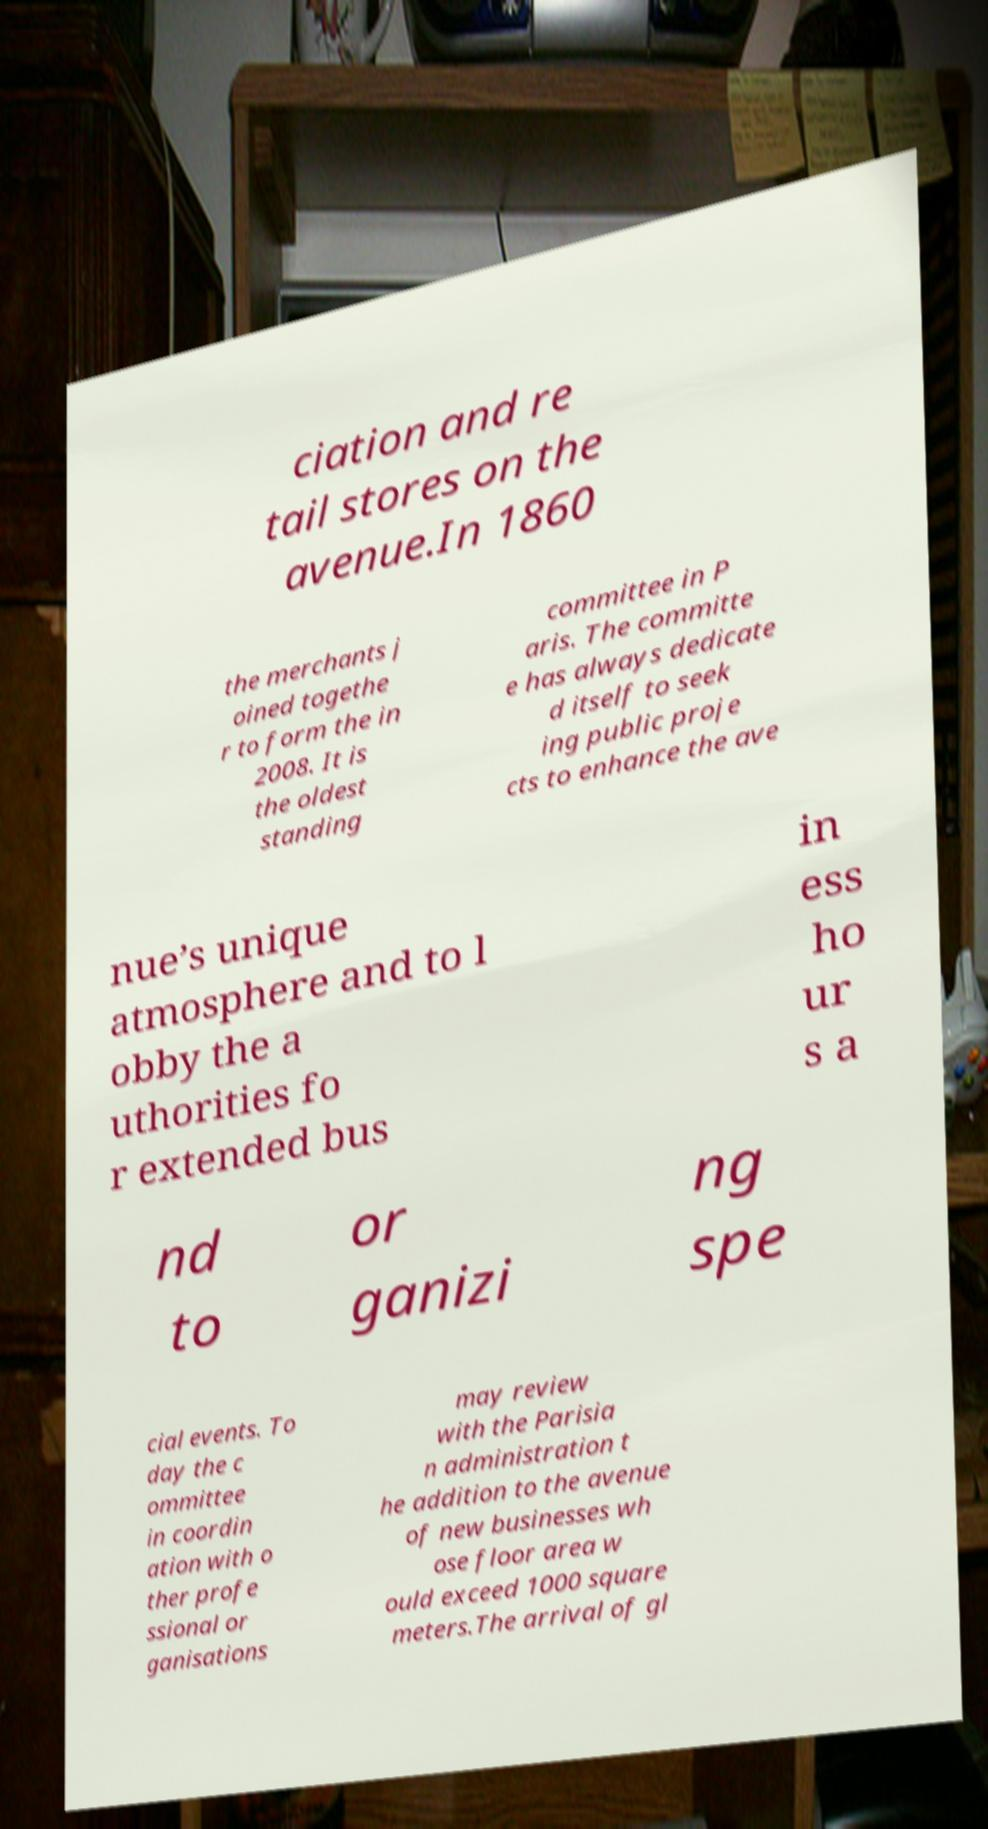I need the written content from this picture converted into text. Can you do that? ciation and re tail stores on the avenue.In 1860 the merchants j oined togethe r to form the in 2008. It is the oldest standing committee in P aris. The committe e has always dedicate d itself to seek ing public proje cts to enhance the ave nue’s unique atmosphere and to l obby the a uthorities fo r extended bus in ess ho ur s a nd to or ganizi ng spe cial events. To day the c ommittee in coordin ation with o ther profe ssional or ganisations may review with the Parisia n administration t he addition to the avenue of new businesses wh ose floor area w ould exceed 1000 square meters.The arrival of gl 